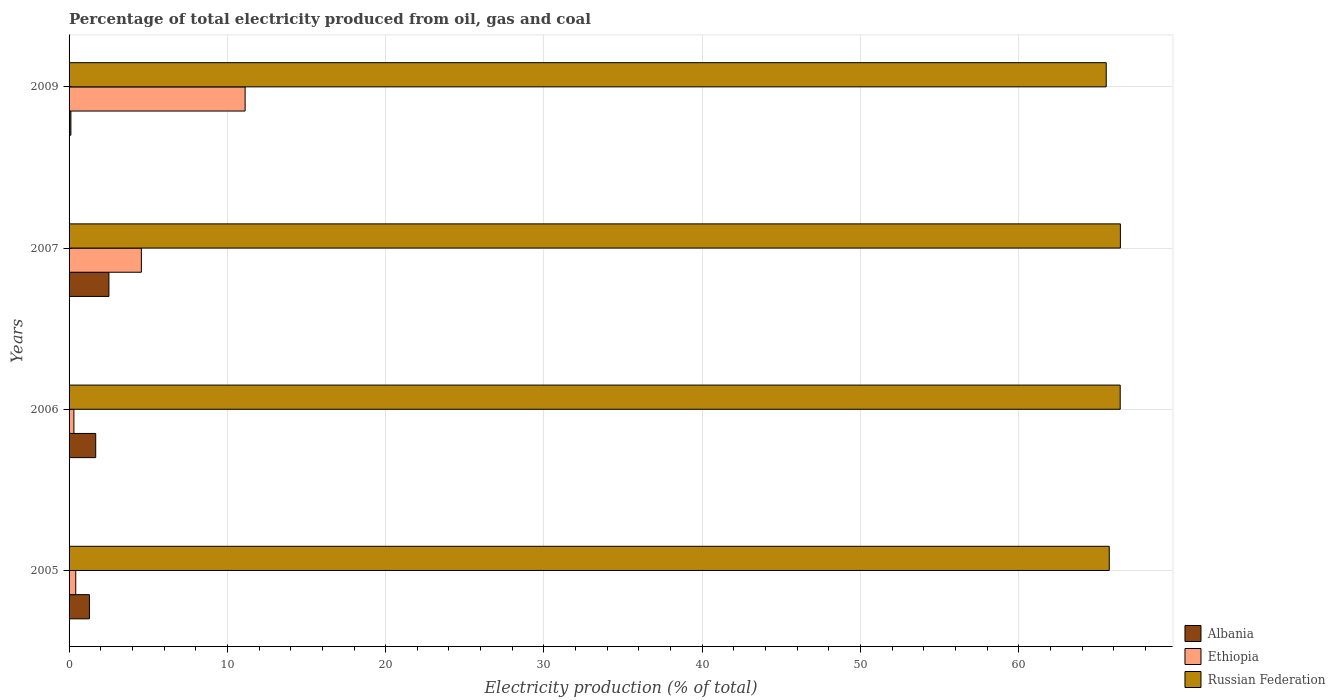How many different coloured bars are there?
Make the answer very short. 3. How many groups of bars are there?
Ensure brevity in your answer.  4. Are the number of bars per tick equal to the number of legend labels?
Offer a very short reply. Yes. How many bars are there on the 3rd tick from the top?
Provide a succinct answer. 3. How many bars are there on the 4th tick from the bottom?
Provide a succinct answer. 3. What is the label of the 3rd group of bars from the top?
Your response must be concise. 2006. In how many cases, is the number of bars for a given year not equal to the number of legend labels?
Your answer should be very brief. 0. What is the electricity production in in Ethiopia in 2009?
Keep it short and to the point. 11.12. Across all years, what is the maximum electricity production in in Ethiopia?
Your answer should be very brief. 11.12. Across all years, what is the minimum electricity production in in Ethiopia?
Your answer should be compact. 0.31. In which year was the electricity production in in Albania minimum?
Make the answer very short. 2009. What is the total electricity production in in Albania in the graph?
Provide a short and direct response. 5.6. What is the difference between the electricity production in in Ethiopia in 2005 and that in 2006?
Give a very brief answer. 0.12. What is the difference between the electricity production in in Russian Federation in 2009 and the electricity production in in Ethiopia in 2007?
Offer a very short reply. 60.95. What is the average electricity production in in Albania per year?
Your answer should be compact. 1.4. In the year 2009, what is the difference between the electricity production in in Russian Federation and electricity production in in Ethiopia?
Your answer should be compact. 54.4. In how many years, is the electricity production in in Albania greater than 26 %?
Offer a very short reply. 0. What is the ratio of the electricity production in in Ethiopia in 2005 to that in 2007?
Give a very brief answer. 0.09. Is the electricity production in in Albania in 2006 less than that in 2007?
Offer a terse response. Yes. Is the difference between the electricity production in in Russian Federation in 2007 and 2009 greater than the difference between the electricity production in in Ethiopia in 2007 and 2009?
Offer a terse response. Yes. What is the difference between the highest and the second highest electricity production in in Albania?
Offer a terse response. 0.83. What is the difference between the highest and the lowest electricity production in in Albania?
Give a very brief answer. 2.4. In how many years, is the electricity production in in Albania greater than the average electricity production in in Albania taken over all years?
Your answer should be very brief. 2. What does the 2nd bar from the top in 2009 represents?
Keep it short and to the point. Ethiopia. What does the 1st bar from the bottom in 2007 represents?
Give a very brief answer. Albania. How many bars are there?
Your answer should be compact. 12. Are all the bars in the graph horizontal?
Provide a succinct answer. Yes. How many years are there in the graph?
Make the answer very short. 4. Does the graph contain grids?
Make the answer very short. Yes. How are the legend labels stacked?
Your answer should be compact. Vertical. What is the title of the graph?
Offer a very short reply. Percentage of total electricity produced from oil, gas and coal. What is the label or title of the X-axis?
Your response must be concise. Electricity production (% of total). What is the Electricity production (% of total) in Albania in 2005?
Your response must be concise. 1.29. What is the Electricity production (% of total) of Ethiopia in 2005?
Keep it short and to the point. 0.42. What is the Electricity production (% of total) in Russian Federation in 2005?
Keep it short and to the point. 65.71. What is the Electricity production (% of total) of Albania in 2006?
Your answer should be very brief. 1.68. What is the Electricity production (% of total) of Ethiopia in 2006?
Provide a short and direct response. 0.31. What is the Electricity production (% of total) of Russian Federation in 2006?
Your answer should be compact. 66.4. What is the Electricity production (% of total) in Albania in 2007?
Offer a terse response. 2.52. What is the Electricity production (% of total) of Ethiopia in 2007?
Offer a very short reply. 4.57. What is the Electricity production (% of total) of Russian Federation in 2007?
Your answer should be compact. 66.42. What is the Electricity production (% of total) in Albania in 2009?
Ensure brevity in your answer.  0.12. What is the Electricity production (% of total) of Ethiopia in 2009?
Provide a succinct answer. 11.12. What is the Electricity production (% of total) of Russian Federation in 2009?
Make the answer very short. 65.52. Across all years, what is the maximum Electricity production (% of total) of Albania?
Give a very brief answer. 2.52. Across all years, what is the maximum Electricity production (% of total) in Ethiopia?
Ensure brevity in your answer.  11.12. Across all years, what is the maximum Electricity production (% of total) of Russian Federation?
Your answer should be compact. 66.42. Across all years, what is the minimum Electricity production (% of total) in Albania?
Ensure brevity in your answer.  0.12. Across all years, what is the minimum Electricity production (% of total) in Ethiopia?
Give a very brief answer. 0.31. Across all years, what is the minimum Electricity production (% of total) of Russian Federation?
Your answer should be compact. 65.52. What is the total Electricity production (% of total) in Albania in the graph?
Your answer should be compact. 5.6. What is the total Electricity production (% of total) in Ethiopia in the graph?
Provide a succinct answer. 16.42. What is the total Electricity production (% of total) in Russian Federation in the graph?
Ensure brevity in your answer.  264.05. What is the difference between the Electricity production (% of total) of Albania in 2005 and that in 2006?
Offer a very short reply. -0.4. What is the difference between the Electricity production (% of total) of Ethiopia in 2005 and that in 2006?
Provide a succinct answer. 0.12. What is the difference between the Electricity production (% of total) in Russian Federation in 2005 and that in 2006?
Keep it short and to the point. -0.69. What is the difference between the Electricity production (% of total) of Albania in 2005 and that in 2007?
Your answer should be very brief. -1.23. What is the difference between the Electricity production (% of total) in Ethiopia in 2005 and that in 2007?
Offer a terse response. -4.15. What is the difference between the Electricity production (% of total) of Russian Federation in 2005 and that in 2007?
Your response must be concise. -0.7. What is the difference between the Electricity production (% of total) in Albania in 2005 and that in 2009?
Provide a short and direct response. 1.17. What is the difference between the Electricity production (% of total) of Ethiopia in 2005 and that in 2009?
Offer a terse response. -10.7. What is the difference between the Electricity production (% of total) of Russian Federation in 2005 and that in 2009?
Your response must be concise. 0.19. What is the difference between the Electricity production (% of total) in Albania in 2006 and that in 2007?
Provide a short and direct response. -0.83. What is the difference between the Electricity production (% of total) in Ethiopia in 2006 and that in 2007?
Provide a short and direct response. -4.26. What is the difference between the Electricity production (% of total) of Russian Federation in 2006 and that in 2007?
Your answer should be compact. -0.01. What is the difference between the Electricity production (% of total) in Albania in 2006 and that in 2009?
Offer a terse response. 1.57. What is the difference between the Electricity production (% of total) of Ethiopia in 2006 and that in 2009?
Your answer should be compact. -10.82. What is the difference between the Electricity production (% of total) in Russian Federation in 2006 and that in 2009?
Offer a very short reply. 0.88. What is the difference between the Electricity production (% of total) in Albania in 2007 and that in 2009?
Offer a terse response. 2.4. What is the difference between the Electricity production (% of total) of Ethiopia in 2007 and that in 2009?
Offer a terse response. -6.55. What is the difference between the Electricity production (% of total) in Russian Federation in 2007 and that in 2009?
Offer a very short reply. 0.9. What is the difference between the Electricity production (% of total) of Albania in 2005 and the Electricity production (% of total) of Ethiopia in 2006?
Offer a terse response. 0.98. What is the difference between the Electricity production (% of total) in Albania in 2005 and the Electricity production (% of total) in Russian Federation in 2006?
Your answer should be very brief. -65.12. What is the difference between the Electricity production (% of total) of Ethiopia in 2005 and the Electricity production (% of total) of Russian Federation in 2006?
Give a very brief answer. -65.98. What is the difference between the Electricity production (% of total) in Albania in 2005 and the Electricity production (% of total) in Ethiopia in 2007?
Provide a short and direct response. -3.28. What is the difference between the Electricity production (% of total) of Albania in 2005 and the Electricity production (% of total) of Russian Federation in 2007?
Offer a very short reply. -65.13. What is the difference between the Electricity production (% of total) in Ethiopia in 2005 and the Electricity production (% of total) in Russian Federation in 2007?
Make the answer very short. -65.99. What is the difference between the Electricity production (% of total) in Albania in 2005 and the Electricity production (% of total) in Ethiopia in 2009?
Your answer should be very brief. -9.84. What is the difference between the Electricity production (% of total) in Albania in 2005 and the Electricity production (% of total) in Russian Federation in 2009?
Your answer should be compact. -64.24. What is the difference between the Electricity production (% of total) in Ethiopia in 2005 and the Electricity production (% of total) in Russian Federation in 2009?
Make the answer very short. -65.1. What is the difference between the Electricity production (% of total) of Albania in 2006 and the Electricity production (% of total) of Ethiopia in 2007?
Your answer should be very brief. -2.88. What is the difference between the Electricity production (% of total) of Albania in 2006 and the Electricity production (% of total) of Russian Federation in 2007?
Your answer should be compact. -64.73. What is the difference between the Electricity production (% of total) of Ethiopia in 2006 and the Electricity production (% of total) of Russian Federation in 2007?
Offer a terse response. -66.11. What is the difference between the Electricity production (% of total) in Albania in 2006 and the Electricity production (% of total) in Ethiopia in 2009?
Offer a very short reply. -9.44. What is the difference between the Electricity production (% of total) of Albania in 2006 and the Electricity production (% of total) of Russian Federation in 2009?
Provide a short and direct response. -63.84. What is the difference between the Electricity production (% of total) of Ethiopia in 2006 and the Electricity production (% of total) of Russian Federation in 2009?
Give a very brief answer. -65.22. What is the difference between the Electricity production (% of total) in Albania in 2007 and the Electricity production (% of total) in Ethiopia in 2009?
Keep it short and to the point. -8.6. What is the difference between the Electricity production (% of total) of Albania in 2007 and the Electricity production (% of total) of Russian Federation in 2009?
Give a very brief answer. -63. What is the difference between the Electricity production (% of total) in Ethiopia in 2007 and the Electricity production (% of total) in Russian Federation in 2009?
Give a very brief answer. -60.95. What is the average Electricity production (% of total) in Albania per year?
Your response must be concise. 1.4. What is the average Electricity production (% of total) in Ethiopia per year?
Provide a short and direct response. 4.1. What is the average Electricity production (% of total) of Russian Federation per year?
Your answer should be compact. 66.01. In the year 2005, what is the difference between the Electricity production (% of total) in Albania and Electricity production (% of total) in Ethiopia?
Keep it short and to the point. 0.86. In the year 2005, what is the difference between the Electricity production (% of total) in Albania and Electricity production (% of total) in Russian Federation?
Your response must be concise. -64.43. In the year 2005, what is the difference between the Electricity production (% of total) of Ethiopia and Electricity production (% of total) of Russian Federation?
Your response must be concise. -65.29. In the year 2006, what is the difference between the Electricity production (% of total) in Albania and Electricity production (% of total) in Ethiopia?
Give a very brief answer. 1.38. In the year 2006, what is the difference between the Electricity production (% of total) of Albania and Electricity production (% of total) of Russian Federation?
Offer a terse response. -64.72. In the year 2006, what is the difference between the Electricity production (% of total) in Ethiopia and Electricity production (% of total) in Russian Federation?
Make the answer very short. -66.1. In the year 2007, what is the difference between the Electricity production (% of total) of Albania and Electricity production (% of total) of Ethiopia?
Your answer should be very brief. -2.05. In the year 2007, what is the difference between the Electricity production (% of total) in Albania and Electricity production (% of total) in Russian Federation?
Keep it short and to the point. -63.9. In the year 2007, what is the difference between the Electricity production (% of total) in Ethiopia and Electricity production (% of total) in Russian Federation?
Provide a succinct answer. -61.85. In the year 2009, what is the difference between the Electricity production (% of total) in Albania and Electricity production (% of total) in Ethiopia?
Your response must be concise. -11.01. In the year 2009, what is the difference between the Electricity production (% of total) in Albania and Electricity production (% of total) in Russian Federation?
Your answer should be compact. -65.41. In the year 2009, what is the difference between the Electricity production (% of total) of Ethiopia and Electricity production (% of total) of Russian Federation?
Offer a very short reply. -54.4. What is the ratio of the Electricity production (% of total) in Albania in 2005 to that in 2006?
Make the answer very short. 0.76. What is the ratio of the Electricity production (% of total) in Ethiopia in 2005 to that in 2006?
Your response must be concise. 1.38. What is the ratio of the Electricity production (% of total) of Russian Federation in 2005 to that in 2006?
Your answer should be compact. 0.99. What is the ratio of the Electricity production (% of total) in Albania in 2005 to that in 2007?
Make the answer very short. 0.51. What is the ratio of the Electricity production (% of total) of Ethiopia in 2005 to that in 2007?
Give a very brief answer. 0.09. What is the ratio of the Electricity production (% of total) in Albania in 2005 to that in 2009?
Your answer should be very brief. 11.16. What is the ratio of the Electricity production (% of total) of Ethiopia in 2005 to that in 2009?
Keep it short and to the point. 0.04. What is the ratio of the Electricity production (% of total) of Russian Federation in 2005 to that in 2009?
Ensure brevity in your answer.  1. What is the ratio of the Electricity production (% of total) of Albania in 2006 to that in 2007?
Keep it short and to the point. 0.67. What is the ratio of the Electricity production (% of total) of Ethiopia in 2006 to that in 2007?
Your answer should be very brief. 0.07. What is the ratio of the Electricity production (% of total) of Albania in 2006 to that in 2009?
Keep it short and to the point. 14.61. What is the ratio of the Electricity production (% of total) of Ethiopia in 2006 to that in 2009?
Ensure brevity in your answer.  0.03. What is the ratio of the Electricity production (% of total) of Russian Federation in 2006 to that in 2009?
Your answer should be very brief. 1.01. What is the ratio of the Electricity production (% of total) in Albania in 2007 to that in 2009?
Ensure brevity in your answer.  21.85. What is the ratio of the Electricity production (% of total) in Ethiopia in 2007 to that in 2009?
Your response must be concise. 0.41. What is the ratio of the Electricity production (% of total) in Russian Federation in 2007 to that in 2009?
Offer a terse response. 1.01. What is the difference between the highest and the second highest Electricity production (% of total) in Albania?
Give a very brief answer. 0.83. What is the difference between the highest and the second highest Electricity production (% of total) of Ethiopia?
Your answer should be compact. 6.55. What is the difference between the highest and the second highest Electricity production (% of total) of Russian Federation?
Keep it short and to the point. 0.01. What is the difference between the highest and the lowest Electricity production (% of total) of Albania?
Make the answer very short. 2.4. What is the difference between the highest and the lowest Electricity production (% of total) of Ethiopia?
Make the answer very short. 10.82. What is the difference between the highest and the lowest Electricity production (% of total) of Russian Federation?
Your response must be concise. 0.9. 